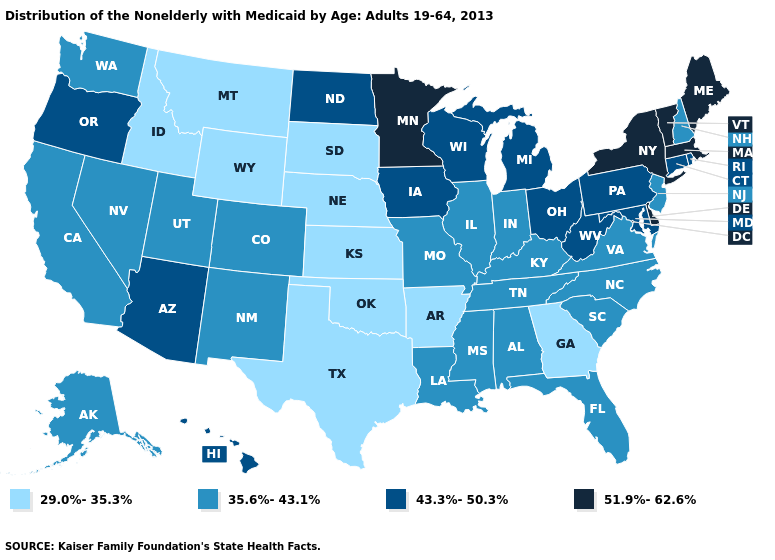What is the highest value in the USA?
Be succinct. 51.9%-62.6%. What is the lowest value in the MidWest?
Give a very brief answer. 29.0%-35.3%. What is the value of Vermont?
Short answer required. 51.9%-62.6%. How many symbols are there in the legend?
Give a very brief answer. 4. Among the states that border Connecticut , does Rhode Island have the lowest value?
Keep it brief. Yes. Which states have the lowest value in the USA?
Quick response, please. Arkansas, Georgia, Idaho, Kansas, Montana, Nebraska, Oklahoma, South Dakota, Texas, Wyoming. What is the value of Delaware?
Give a very brief answer. 51.9%-62.6%. Among the states that border Colorado , does New Mexico have the lowest value?
Give a very brief answer. No. What is the value of California?
Give a very brief answer. 35.6%-43.1%. Does the map have missing data?
Quick response, please. No. Which states have the lowest value in the West?
Write a very short answer. Idaho, Montana, Wyoming. Name the states that have a value in the range 35.6%-43.1%?
Be succinct. Alabama, Alaska, California, Colorado, Florida, Illinois, Indiana, Kentucky, Louisiana, Mississippi, Missouri, Nevada, New Hampshire, New Jersey, New Mexico, North Carolina, South Carolina, Tennessee, Utah, Virginia, Washington. Does Kansas have the same value as Montana?
Write a very short answer. Yes. What is the value of Maryland?
Concise answer only. 43.3%-50.3%. 